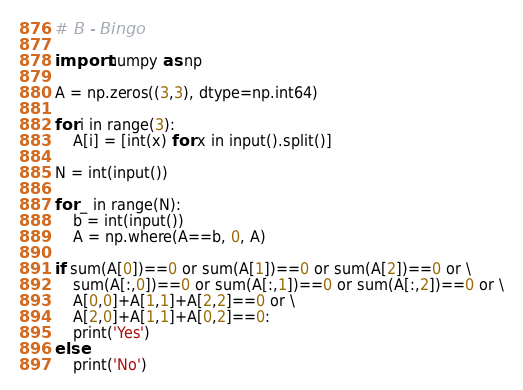Convert code to text. <code><loc_0><loc_0><loc_500><loc_500><_Python_># B - Bingo

import numpy as np

A = np.zeros((3,3), dtype=np.int64)

for i in range(3):
    A[i] = [int(x) for x in input().split()]

N = int(input())

for _ in range(N):
    b = int(input())
    A = np.where(A==b, 0, A)

if sum(A[0])==0 or sum(A[1])==0 or sum(A[2])==0 or \
    sum(A[:,0])==0 or sum(A[:,1])==0 or sum(A[:,2])==0 or \
    A[0,0]+A[1,1]+A[2,2]==0 or \
    A[2,0]+A[1,1]+A[0,2]==0:
    print('Yes')
else:
    print('No')</code> 